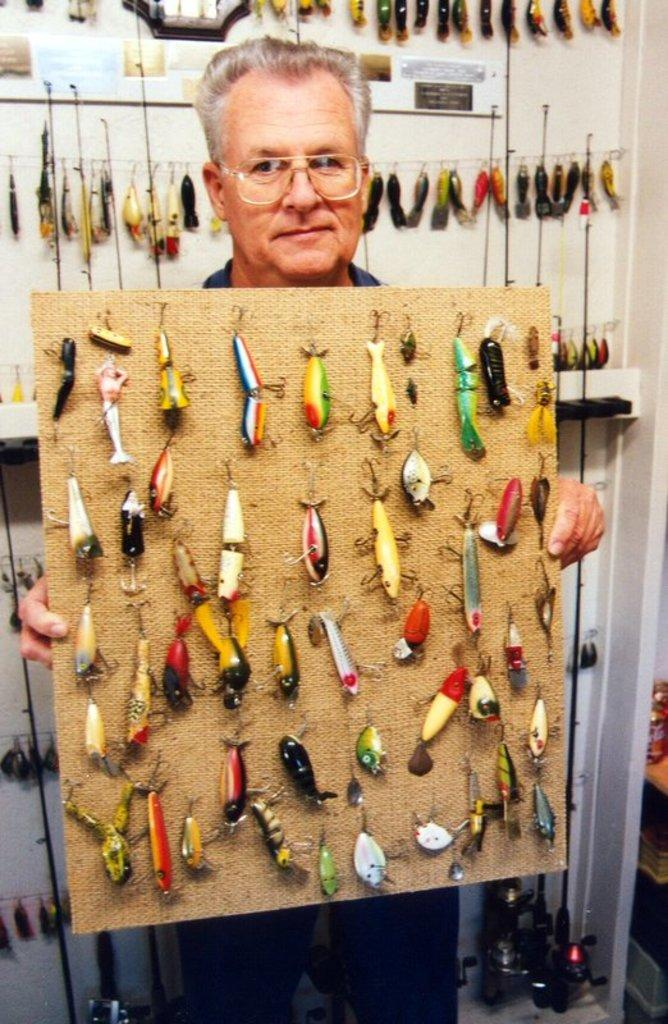What is the person in the image holding? The person is holding a board in the image. What can be seen on the board? There are objects on the board. What is hanging in the background of the image? There are objects hanging on a wire in the background of the image. Where is the wire located in relation to the wall? The wire is near a wall. What type of straw is growing in the wilderness in the image? There is no straw or wilderness present in the image. 